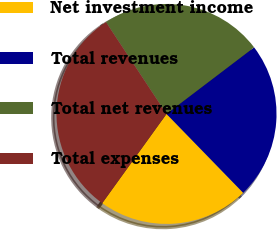Convert chart. <chart><loc_0><loc_0><loc_500><loc_500><pie_chart><fcel>Net investment income<fcel>Total revenues<fcel>Total net revenues<fcel>Total expenses<nl><fcel>22.21%<fcel>23.07%<fcel>23.93%<fcel>30.79%<nl></chart> 